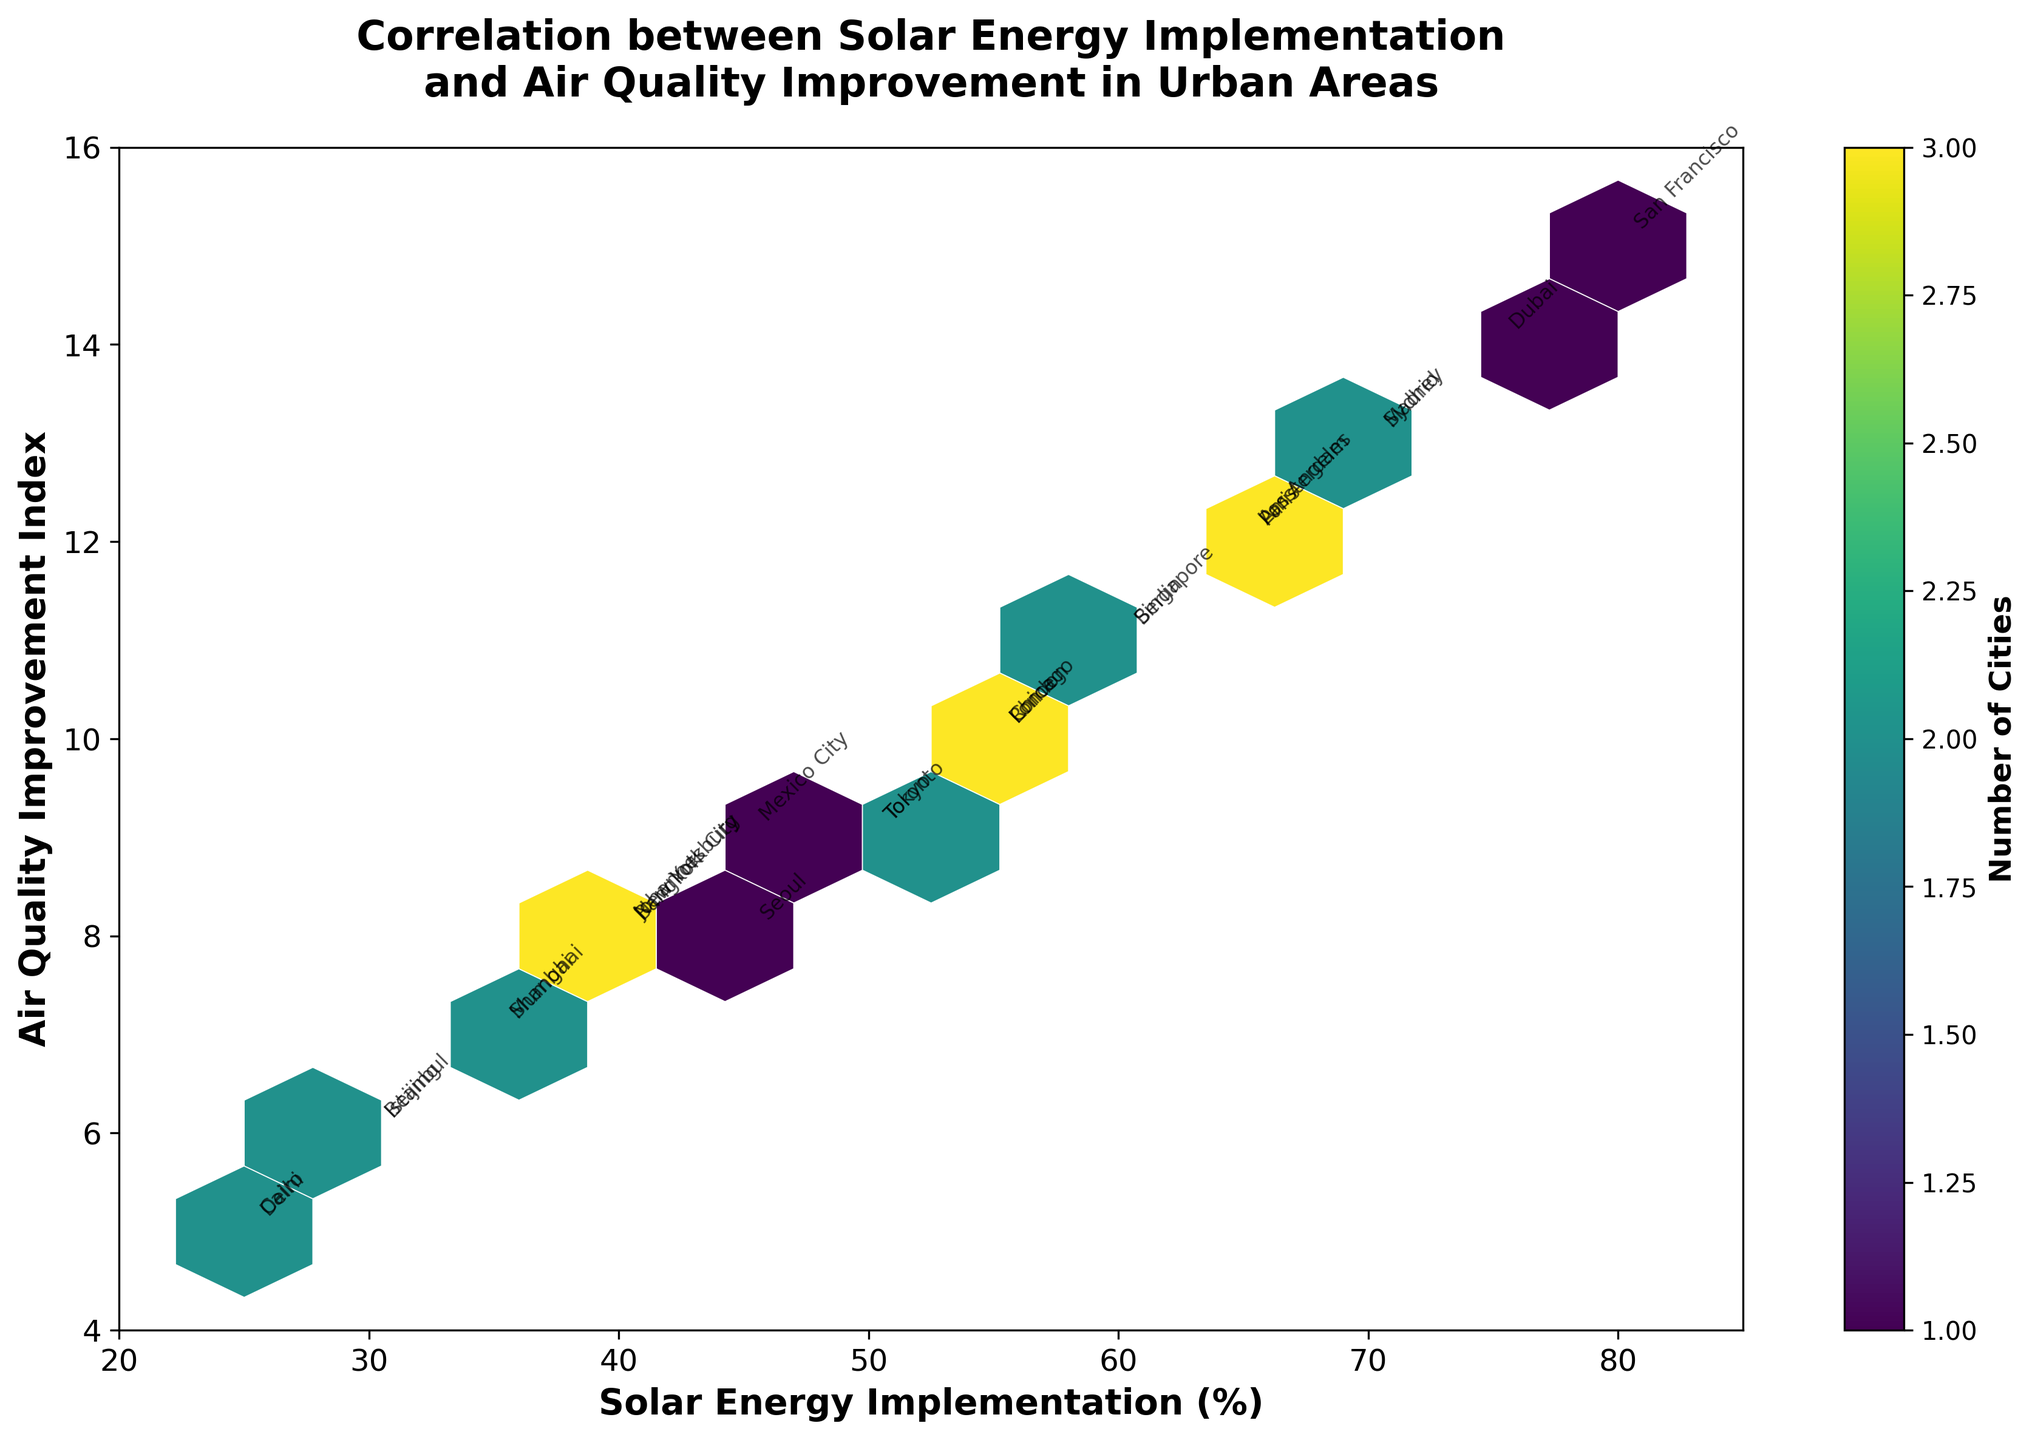what is the title of the figure? The title is displayed at the top of the figure, providing a summary of the plot's content. In this case, the title describes the correlation being analyzed.
Answer: Correlation between Solar Energy Implementation and Air Quality Improvement in Urban Areas How many cities have data points on the plot? Each unique city represented by a label corresponds to a data point. Count all the city labels present in the figure.
Answer: 24 Which city has the highest solar energy implementation? Los Angeles and Dubai have the highest solar energy implementation because their implementation percentage (as indicated on the x-axis) is 75%, which is the highest value on the plot.
Answer: Dubai Which city shows the least air quality improvement? The least air quality improvement can be found by looking for the lowest value on the y-axis. In this plot, cities like Istanbul and Delhi, with a value of 5, have the least improvement.
Answer: Delhi Are there more cities with solar energy implementation above 50% or below 50%? Divide the x-axis into two segments, above and below 50%, then count the number of cities' data points in each segment. Compare the counts to determine which segment has more cities.
Answer: Above 50% Identify the city with a solar energy implementation closest to 60% and an air quality improvement index around 11. Locate the data points near x = 60% and y = 11. Berlin and Singapore are the cities that fit this description.
Answer: Berlin What's the range of solar energy implementation percentages across all cities? Identify the minimum and maximum values on the x-axis and calculate the difference between them. The lowest percentage is 25%, and the highest is 80%.
Answer: 55% What color represents the highest density of cities in the plot? The hexagonal bins in the plot use a color gradient to represent density, with brighter or different colors indicating higher density. Identify the color used for the densest regions.
Answer: Yellow Which two cities are closest in air quality improvement but have different levels of solar energy implementation? Look for pairs of cities at similar y-axis values but different x-axis values. For instance, Berlin and Singapore both have an improvement index of 11, but different levels of solar energy.
Answer: Berlin and Singapore How does the air quality improvement index change with increasing solar energy implementation? Observing the general trend in the scatter of points while increasing x-axis values will provide insights. Higher solar energy implementation generally correlates with a higher air quality improvement index.
Answer: Generally increases 